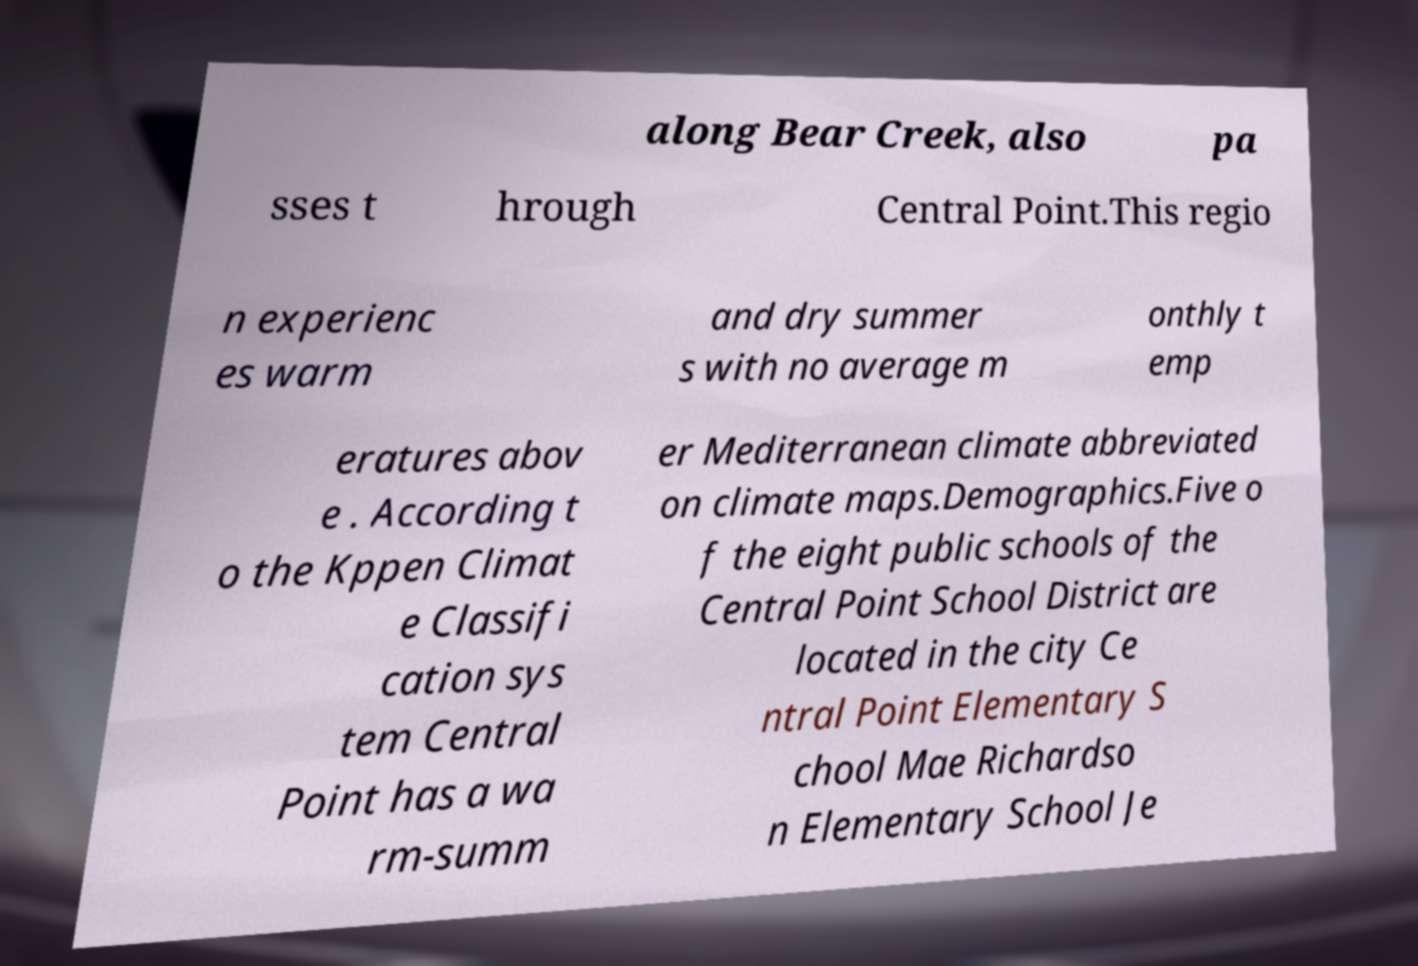Please read and relay the text visible in this image. What does it say? along Bear Creek, also pa sses t hrough Central Point.This regio n experienc es warm and dry summer s with no average m onthly t emp eratures abov e . According t o the Kppen Climat e Classifi cation sys tem Central Point has a wa rm-summ er Mediterranean climate abbreviated on climate maps.Demographics.Five o f the eight public schools of the Central Point School District are located in the city Ce ntral Point Elementary S chool Mae Richardso n Elementary School Je 